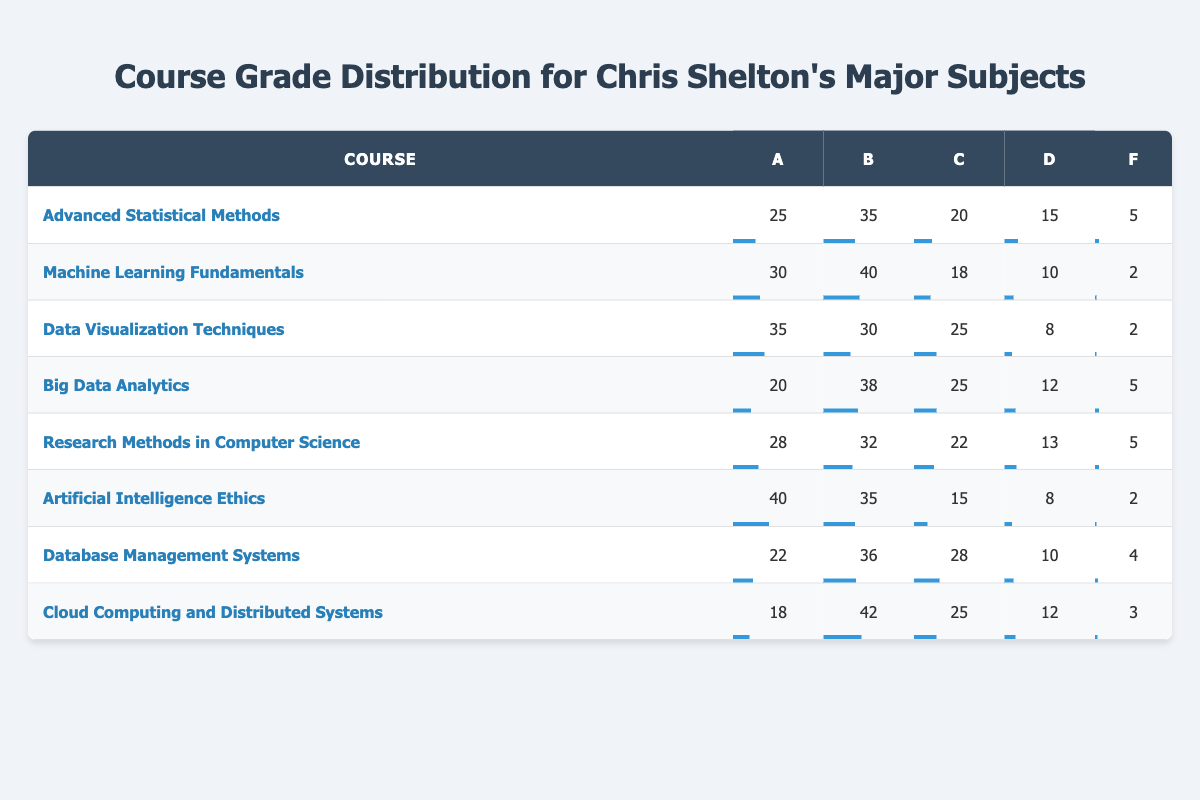What is the maximum number of students who received an A in any course? Looking at the A column, the maximum value is 40, which corresponds to the course "Artificial Intelligence Ethics."
Answer: 40 Which course had the least number of students receiving a grade of F? In the F column, the minimum value is 2, which occurs in two courses: "Machine Learning Fundamentals" and "Artificial Intelligence Ethics."
Answer: 2 What is the total number of students who passed (A, B, and C) in "Big Data Analytics"? To find the number of students who passed, we add the values in columns A, B, and C for the course "Big Data Analytics": 20 + 38 + 25 = 83.
Answer: 83 Calculate the average number of students who got a C across all courses. The values for C across the courses are 20, 18, 25, 25, 22, 15, 28, and 25. Adding these gives 20 + 18 + 25 + 25 + 22 + 15 + 28 + 25 = 178. There are 8 courses, so the average is 178 / 8 = 22.25.
Answer: 22.25 Is it true that more students received a grade of B in "Cloud Computing and Distributed Systems" than in "Database Management Systems"? The number of students who got a B in "Cloud Computing and Distributed Systems" is 42, whereas in "Database Management Systems," it is 36. Since 42 is greater than 36, the statement is true.
Answer: Yes Which course had the highest percentage of A grades compared to total grades? To find the percentage for each course, we need to calculate the total number of grades for each course and find the percentage of A grades. For each course, the percentages are: "Advanced Statistical Methods" (25/100 = 25%), "Machine Learning Fundamentals" (30/100 = 30%), "Data Visualization Techniques" (35/100 = 35%), "Big Data Analytics" (20/100 = 20%), "Research Methods in Computer Science" (28/100 = 28%), "Artificial Intelligence Ethics" (40/100 = 40%), "Database Management Systems" (22/100 = 22%), and "Cloud Computing and Distributed Systems" (18/100 = 18%). The highest percentage is 40% for "Artificial Intelligence Ethics."
Answer: "Artificial Intelligence Ethics" How many students received a grade of D in "Data Visualization Techniques"? Looking at the D column for "Data Visualization Techniques," the value is 8, indicating 8 students received a D.
Answer: 8 What is the combined number of students who received an A across "Machine Learning Fundamentals" and "Cloud Computing and Distributed Systems"? The number of students who received an A in "Machine Learning Fundamentals" is 30, and in "Cloud Computing and Distributed Systems," it is 18. Adding these gives 30 + 18 = 48.
Answer: 48 Was the number of students receiving a grade of C in "Artificial Intelligence Ethics" greater than those receiving an F in "Advanced Statistical Methods"? The number of students who received a C in "Artificial Intelligence Ethics" is 15, while those who received an F in "Advanced Statistical Methods" is 5. Since 15 is greater than 5, the statement is true.
Answer: Yes 